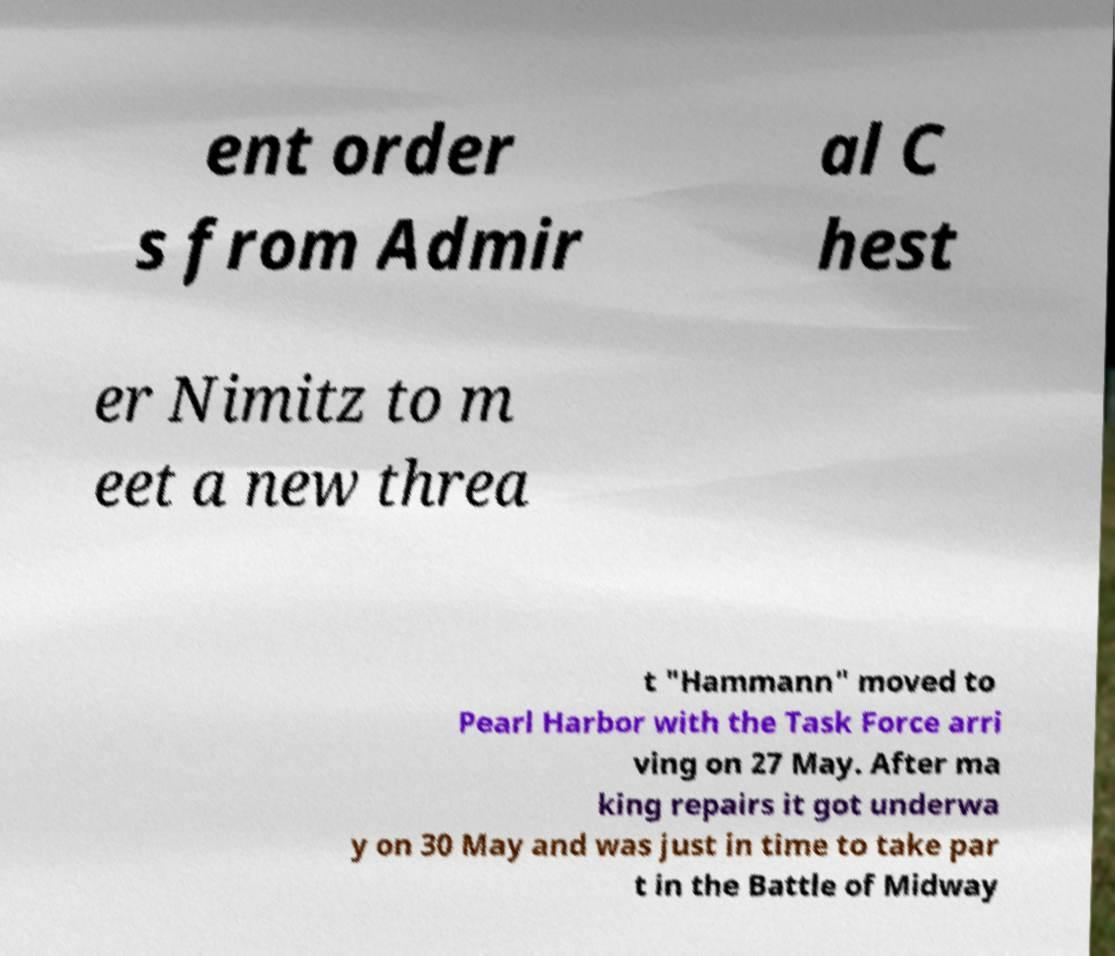Could you extract and type out the text from this image? ent order s from Admir al C hest er Nimitz to m eet a new threa t "Hammann" moved to Pearl Harbor with the Task Force arri ving on 27 May. After ma king repairs it got underwa y on 30 May and was just in time to take par t in the Battle of Midway 